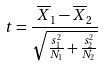Convert formula to latex. <formula><loc_0><loc_0><loc_500><loc_500>t = \frac { \overline { X } _ { 1 } - \overline { X } _ { 2 } } { \sqrt { \frac { s _ { 1 } ^ { 2 } } { N _ { 1 } } + \frac { s _ { 2 } ^ { 2 } } { N _ { 2 } } } }</formula> 